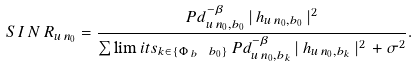Convert formula to latex. <formula><loc_0><loc_0><loc_500><loc_500>S \, I \, N \, R _ { u \, n _ { 0 } } = \frac { P d _ { u \, n _ { 0 } , b _ { 0 } } ^ { - \beta } \, | \, h _ { u \, n _ { 0 } , b _ { 0 } } \, | ^ { 2 } } { \sum \lim i t s _ { k \in \{ \Phi \, _ { b } \, \ b _ { 0 } \} } \, P d _ { u \, n _ { 0 } , b _ { k } } ^ { - \beta } \, | \, h _ { u \, n _ { 0 } , b _ { k } } \, | ^ { 2 } \, + \sigma ^ { 2 } } .</formula> 